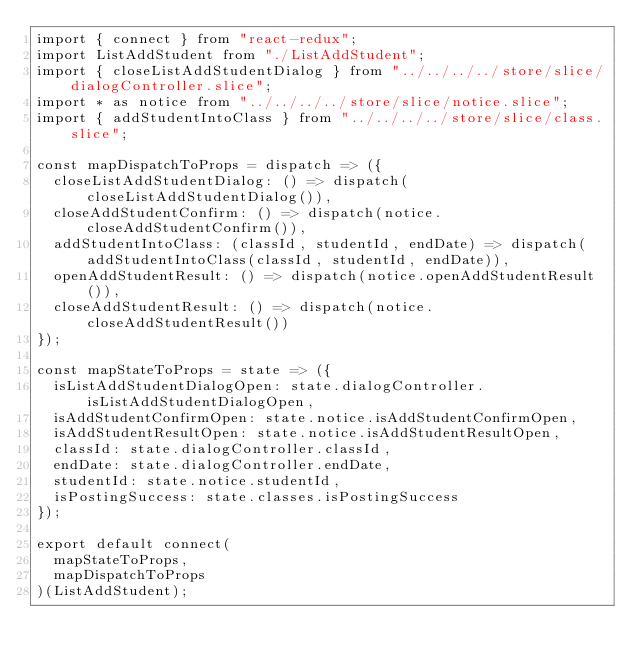Convert code to text. <code><loc_0><loc_0><loc_500><loc_500><_JavaScript_>import { connect } from "react-redux";
import ListAddStudent from "./ListAddStudent";
import { closeListAddStudentDialog } from "../../../../store/slice/dialogController.slice";
import * as notice from "../../../../store/slice/notice.slice";
import { addStudentIntoClass } from "../../../../store/slice/class.slice";

const mapDispatchToProps = dispatch => ({
  closeListAddStudentDialog: () => dispatch(closeListAddStudentDialog()),
  closeAddStudentConfirm: () => dispatch(notice.closeAddStudentConfirm()),
  addStudentIntoClass: (classId, studentId, endDate) => dispatch(addStudentIntoClass(classId, studentId, endDate)),
  openAddStudentResult: () => dispatch(notice.openAddStudentResult()),
  closeAddStudentResult: () => dispatch(notice.closeAddStudentResult())
});

const mapStateToProps = state => ({
  isListAddStudentDialogOpen: state.dialogController.isListAddStudentDialogOpen,
  isAddStudentConfirmOpen: state.notice.isAddStudentConfirmOpen,
  isAddStudentResultOpen: state.notice.isAddStudentResultOpen,
  classId: state.dialogController.classId,
  endDate: state.dialogController.endDate,
  studentId: state.notice.studentId,
  isPostingSuccess: state.classes.isPostingSuccess
});

export default connect(
  mapStateToProps,
  mapDispatchToProps
)(ListAddStudent);
</code> 